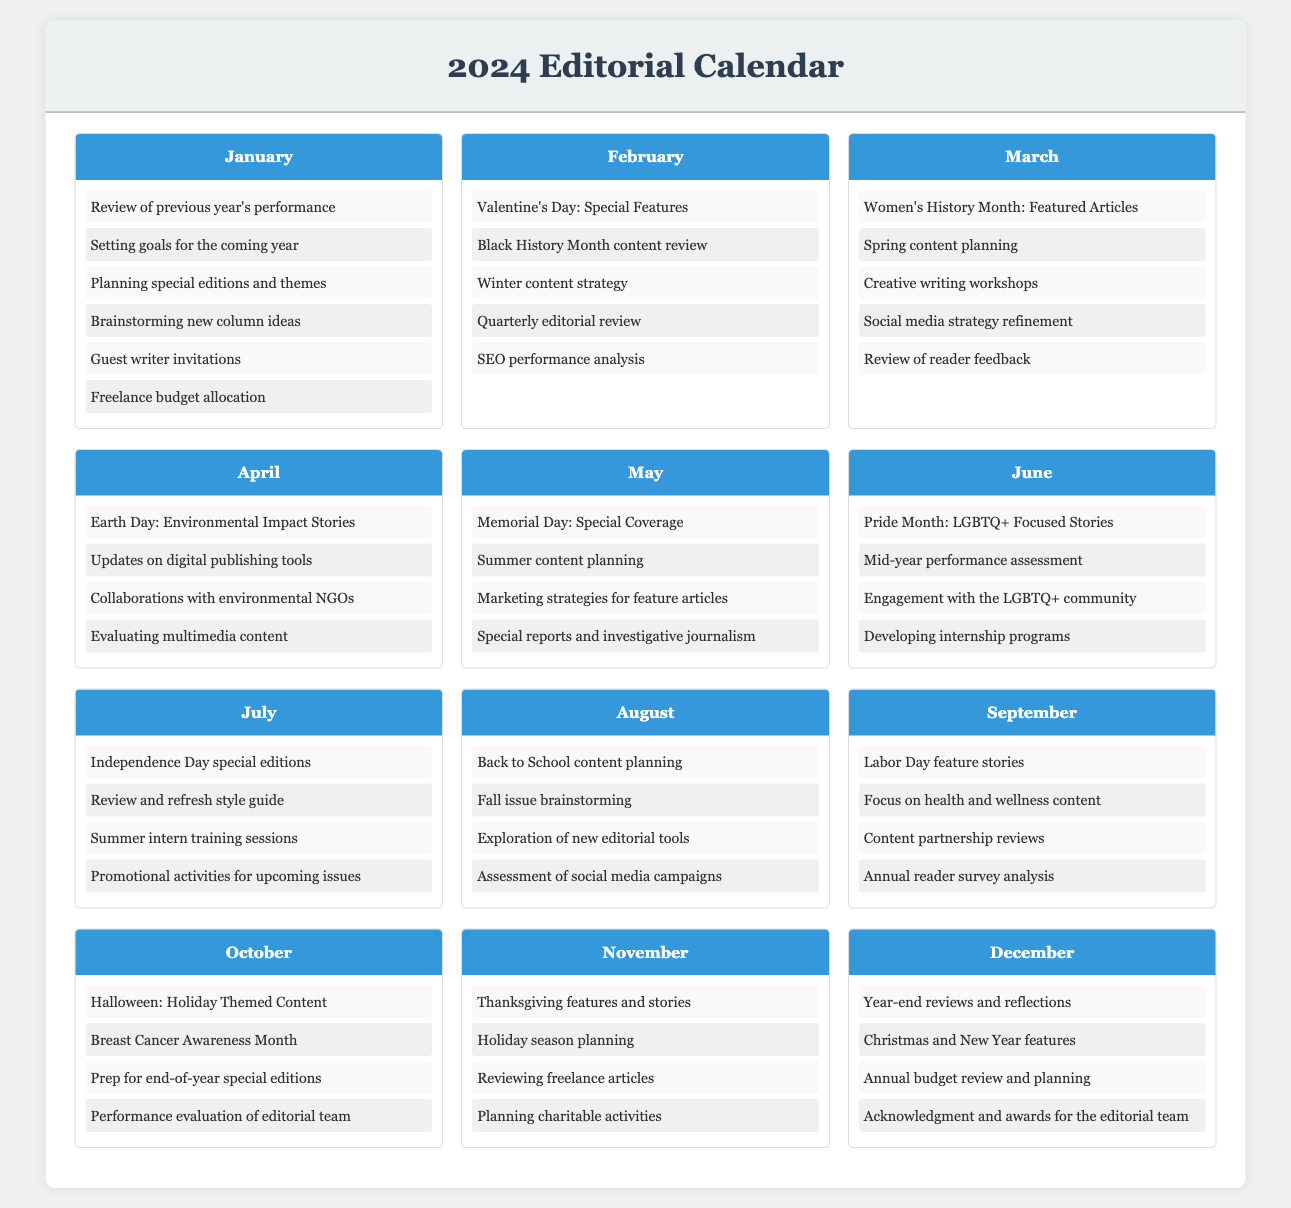what is the first agenda item for January? The first agenda item listed for January is a review of previous year's performance.
Answer: Review of previous year's performance how many agenda items are listed for September? The document specifies four agenda items for September.
Answer: 4 which month includes Pride Month content? The month that includes Pride Month content is June.
Answer: June what special feature is planned for October? The special feature planned for October is Halloween-themed content.
Answer: Halloween: Holiday Themed Content which month involves a mid-year performance assessment? The month that involves a mid-year performance assessment is June.
Answer: June how many total months are covered in the editorial calendar? The editorial calendar covers a total of twelve months.
Answer: 12 what is the main focus for February? The main focus for February includes Valentine's Day and Black History Month content.
Answer: Valentine's Day: Special Features which month features Thanksgiving stories? The month that features Thanksgiving stories is November.
Answer: November what type of reviews take place in the third month of the year? In March, the reviews focus on Women's History Month and reader feedback.
Answer: Women's History Month: Featured Articles 